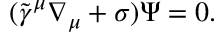<formula> <loc_0><loc_0><loc_500><loc_500>( \tilde { \gamma } ^ { \mu } \nabla _ { \mu } + \sigma ) \Psi = 0 .</formula> 